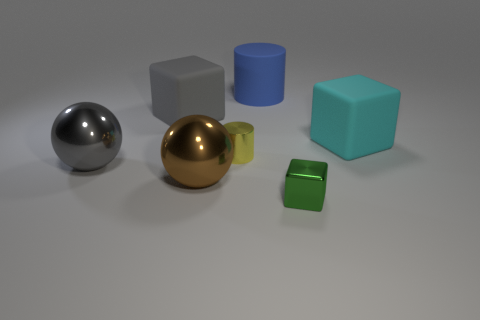Do the large cube that is behind the cyan rubber thing and the big brown sphere have the same material?
Provide a succinct answer. No. There is a cube that is right of the tiny shiny thing to the right of the blue cylinder; are there any tiny cubes behind it?
Provide a succinct answer. No. How many balls are large gray metallic things or green objects?
Make the answer very short. 1. What material is the big cube that is behind the cyan thing?
Offer a very short reply. Rubber. Is the color of the big cube on the right side of the big blue thing the same as the rubber cube that is on the left side of the brown thing?
Provide a succinct answer. No. What number of things are large gray shiny spheres or large metal objects?
Your answer should be very brief. 2. What number of other things are the same shape as the small yellow metallic object?
Give a very brief answer. 1. Are the sphere behind the brown object and the cube in front of the gray sphere made of the same material?
Your answer should be compact. Yes. What shape is the thing that is in front of the big cyan rubber cube and behind the gray shiny ball?
Offer a very short reply. Cylinder. Is there any other thing that is the same material as the cyan thing?
Provide a succinct answer. Yes. 